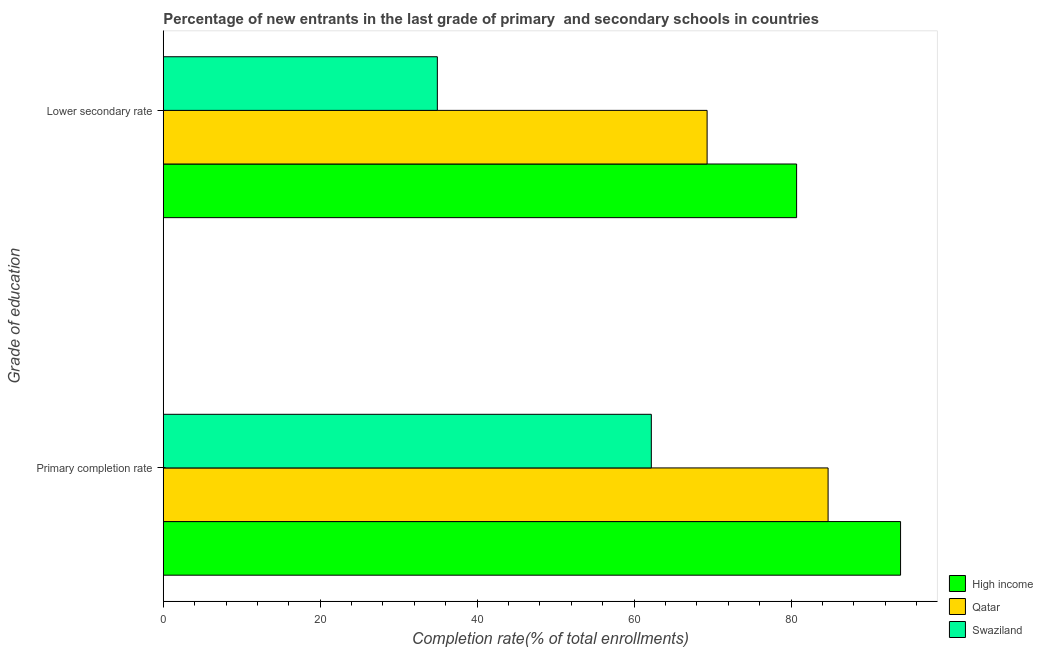How many different coloured bars are there?
Provide a succinct answer. 3. How many groups of bars are there?
Give a very brief answer. 2. How many bars are there on the 1st tick from the top?
Offer a very short reply. 3. How many bars are there on the 1st tick from the bottom?
Provide a short and direct response. 3. What is the label of the 2nd group of bars from the top?
Your response must be concise. Primary completion rate. What is the completion rate in primary schools in Swaziland?
Provide a short and direct response. 62.2. Across all countries, what is the maximum completion rate in primary schools?
Your answer should be very brief. 93.96. Across all countries, what is the minimum completion rate in secondary schools?
Keep it short and to the point. 34.93. In which country was the completion rate in primary schools maximum?
Your answer should be very brief. High income. In which country was the completion rate in primary schools minimum?
Ensure brevity in your answer.  Swaziland. What is the total completion rate in primary schools in the graph?
Provide a succinct answer. 240.88. What is the difference between the completion rate in secondary schools in Swaziland and that in Qatar?
Make the answer very short. -34.38. What is the difference between the completion rate in secondary schools in Qatar and the completion rate in primary schools in Swaziland?
Make the answer very short. 7.11. What is the average completion rate in secondary schools per country?
Your answer should be compact. 61.65. What is the difference between the completion rate in secondary schools and completion rate in primary schools in Swaziland?
Provide a short and direct response. -27.27. In how many countries, is the completion rate in primary schools greater than 44 %?
Your response must be concise. 3. What is the ratio of the completion rate in primary schools in High income to that in Swaziland?
Offer a terse response. 1.51. Is the completion rate in secondary schools in Qatar less than that in Swaziland?
Your answer should be very brief. No. In how many countries, is the completion rate in primary schools greater than the average completion rate in primary schools taken over all countries?
Ensure brevity in your answer.  2. What does the 2nd bar from the top in Lower secondary rate represents?
Your answer should be compact. Qatar. What does the 2nd bar from the bottom in Primary completion rate represents?
Keep it short and to the point. Qatar. How many countries are there in the graph?
Provide a succinct answer. 3. What is the difference between two consecutive major ticks on the X-axis?
Provide a short and direct response. 20. Are the values on the major ticks of X-axis written in scientific E-notation?
Keep it short and to the point. No. Does the graph contain grids?
Ensure brevity in your answer.  No. How many legend labels are there?
Your answer should be compact. 3. What is the title of the graph?
Your answer should be very brief. Percentage of new entrants in the last grade of primary  and secondary schools in countries. What is the label or title of the X-axis?
Provide a short and direct response. Completion rate(% of total enrollments). What is the label or title of the Y-axis?
Your answer should be very brief. Grade of education. What is the Completion rate(% of total enrollments) in High income in Primary completion rate?
Provide a short and direct response. 93.96. What is the Completion rate(% of total enrollments) of Qatar in Primary completion rate?
Offer a very short reply. 84.72. What is the Completion rate(% of total enrollments) in Swaziland in Primary completion rate?
Provide a succinct answer. 62.2. What is the Completion rate(% of total enrollments) of High income in Lower secondary rate?
Offer a terse response. 80.71. What is the Completion rate(% of total enrollments) in Qatar in Lower secondary rate?
Provide a succinct answer. 69.3. What is the Completion rate(% of total enrollments) of Swaziland in Lower secondary rate?
Your response must be concise. 34.93. Across all Grade of education, what is the maximum Completion rate(% of total enrollments) in High income?
Offer a very short reply. 93.96. Across all Grade of education, what is the maximum Completion rate(% of total enrollments) of Qatar?
Give a very brief answer. 84.72. Across all Grade of education, what is the maximum Completion rate(% of total enrollments) in Swaziland?
Provide a succinct answer. 62.2. Across all Grade of education, what is the minimum Completion rate(% of total enrollments) of High income?
Provide a short and direct response. 80.71. Across all Grade of education, what is the minimum Completion rate(% of total enrollments) of Qatar?
Your response must be concise. 69.3. Across all Grade of education, what is the minimum Completion rate(% of total enrollments) of Swaziland?
Provide a succinct answer. 34.93. What is the total Completion rate(% of total enrollments) in High income in the graph?
Provide a short and direct response. 174.67. What is the total Completion rate(% of total enrollments) of Qatar in the graph?
Your answer should be compact. 154.03. What is the total Completion rate(% of total enrollments) of Swaziland in the graph?
Your answer should be very brief. 97.12. What is the difference between the Completion rate(% of total enrollments) of High income in Primary completion rate and that in Lower secondary rate?
Ensure brevity in your answer.  13.25. What is the difference between the Completion rate(% of total enrollments) of Qatar in Primary completion rate and that in Lower secondary rate?
Your answer should be compact. 15.42. What is the difference between the Completion rate(% of total enrollments) of Swaziland in Primary completion rate and that in Lower secondary rate?
Your response must be concise. 27.27. What is the difference between the Completion rate(% of total enrollments) in High income in Primary completion rate and the Completion rate(% of total enrollments) in Qatar in Lower secondary rate?
Give a very brief answer. 24.65. What is the difference between the Completion rate(% of total enrollments) of High income in Primary completion rate and the Completion rate(% of total enrollments) of Swaziland in Lower secondary rate?
Ensure brevity in your answer.  59.03. What is the difference between the Completion rate(% of total enrollments) in Qatar in Primary completion rate and the Completion rate(% of total enrollments) in Swaziland in Lower secondary rate?
Your response must be concise. 49.8. What is the average Completion rate(% of total enrollments) in High income per Grade of education?
Your answer should be compact. 87.33. What is the average Completion rate(% of total enrollments) in Qatar per Grade of education?
Provide a succinct answer. 77.01. What is the average Completion rate(% of total enrollments) of Swaziland per Grade of education?
Make the answer very short. 48.56. What is the difference between the Completion rate(% of total enrollments) of High income and Completion rate(% of total enrollments) of Qatar in Primary completion rate?
Keep it short and to the point. 9.23. What is the difference between the Completion rate(% of total enrollments) of High income and Completion rate(% of total enrollments) of Swaziland in Primary completion rate?
Ensure brevity in your answer.  31.76. What is the difference between the Completion rate(% of total enrollments) in Qatar and Completion rate(% of total enrollments) in Swaziland in Primary completion rate?
Your answer should be very brief. 22.53. What is the difference between the Completion rate(% of total enrollments) of High income and Completion rate(% of total enrollments) of Qatar in Lower secondary rate?
Your answer should be very brief. 11.41. What is the difference between the Completion rate(% of total enrollments) of High income and Completion rate(% of total enrollments) of Swaziland in Lower secondary rate?
Ensure brevity in your answer.  45.78. What is the difference between the Completion rate(% of total enrollments) of Qatar and Completion rate(% of total enrollments) of Swaziland in Lower secondary rate?
Provide a succinct answer. 34.38. What is the ratio of the Completion rate(% of total enrollments) of High income in Primary completion rate to that in Lower secondary rate?
Offer a terse response. 1.16. What is the ratio of the Completion rate(% of total enrollments) of Qatar in Primary completion rate to that in Lower secondary rate?
Your answer should be very brief. 1.22. What is the ratio of the Completion rate(% of total enrollments) of Swaziland in Primary completion rate to that in Lower secondary rate?
Give a very brief answer. 1.78. What is the difference between the highest and the second highest Completion rate(% of total enrollments) of High income?
Your response must be concise. 13.25. What is the difference between the highest and the second highest Completion rate(% of total enrollments) in Qatar?
Provide a succinct answer. 15.42. What is the difference between the highest and the second highest Completion rate(% of total enrollments) in Swaziland?
Ensure brevity in your answer.  27.27. What is the difference between the highest and the lowest Completion rate(% of total enrollments) in High income?
Your response must be concise. 13.25. What is the difference between the highest and the lowest Completion rate(% of total enrollments) of Qatar?
Offer a terse response. 15.42. What is the difference between the highest and the lowest Completion rate(% of total enrollments) of Swaziland?
Your answer should be very brief. 27.27. 